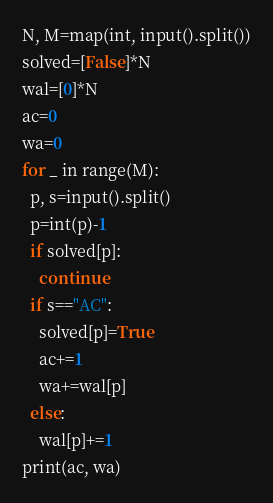Convert code to text. <code><loc_0><loc_0><loc_500><loc_500><_Python_>N, M=map(int, input().split())
solved=[False]*N
wal=[0]*N
ac=0
wa=0
for _ in range(M):
  p, s=input().split()
  p=int(p)-1
  if solved[p]:
    continue
  if s=="AC":
    solved[p]=True
    ac+=1
    wa+=wal[p]
  else:
    wal[p]+=1
print(ac, wa)  </code> 